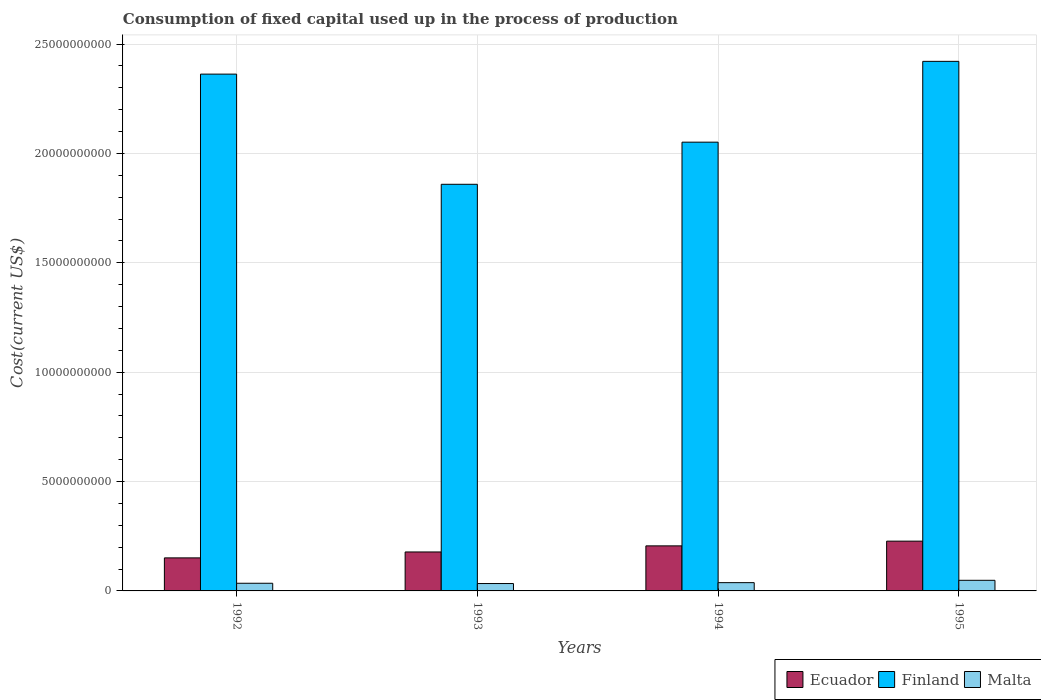How many different coloured bars are there?
Provide a short and direct response. 3. How many bars are there on the 4th tick from the right?
Ensure brevity in your answer.  3. What is the amount consumed in the process of production in Ecuador in 1995?
Give a very brief answer. 2.28e+09. Across all years, what is the maximum amount consumed in the process of production in Finland?
Make the answer very short. 2.42e+1. Across all years, what is the minimum amount consumed in the process of production in Ecuador?
Your answer should be compact. 1.51e+09. In which year was the amount consumed in the process of production in Ecuador maximum?
Your answer should be compact. 1995. In which year was the amount consumed in the process of production in Malta minimum?
Provide a short and direct response. 1993. What is the total amount consumed in the process of production in Malta in the graph?
Ensure brevity in your answer.  1.55e+09. What is the difference between the amount consumed in the process of production in Finland in 1992 and that in 1993?
Keep it short and to the point. 5.04e+09. What is the difference between the amount consumed in the process of production in Ecuador in 1994 and the amount consumed in the process of production in Finland in 1995?
Provide a short and direct response. -2.22e+1. What is the average amount consumed in the process of production in Finland per year?
Your answer should be very brief. 2.17e+1. In the year 1995, what is the difference between the amount consumed in the process of production in Ecuador and amount consumed in the process of production in Malta?
Your response must be concise. 1.79e+09. What is the ratio of the amount consumed in the process of production in Ecuador in 1992 to that in 1994?
Your answer should be very brief. 0.73. What is the difference between the highest and the second highest amount consumed in the process of production in Finland?
Give a very brief answer. 5.84e+08. What is the difference between the highest and the lowest amount consumed in the process of production in Malta?
Your response must be concise. 1.48e+08. Is the sum of the amount consumed in the process of production in Malta in 1992 and 1995 greater than the maximum amount consumed in the process of production in Finland across all years?
Keep it short and to the point. No. What does the 2nd bar from the left in 1992 represents?
Make the answer very short. Finland. What does the 1st bar from the right in 1994 represents?
Ensure brevity in your answer.  Malta. Is it the case that in every year, the sum of the amount consumed in the process of production in Finland and amount consumed in the process of production in Ecuador is greater than the amount consumed in the process of production in Malta?
Keep it short and to the point. Yes. Are all the bars in the graph horizontal?
Give a very brief answer. No. Are the values on the major ticks of Y-axis written in scientific E-notation?
Provide a succinct answer. No. Does the graph contain any zero values?
Ensure brevity in your answer.  No. Where does the legend appear in the graph?
Keep it short and to the point. Bottom right. What is the title of the graph?
Give a very brief answer. Consumption of fixed capital used up in the process of production. Does "Tajikistan" appear as one of the legend labels in the graph?
Your answer should be very brief. No. What is the label or title of the X-axis?
Give a very brief answer. Years. What is the label or title of the Y-axis?
Give a very brief answer. Cost(current US$). What is the Cost(current US$) in Ecuador in 1992?
Keep it short and to the point. 1.51e+09. What is the Cost(current US$) in Finland in 1992?
Make the answer very short. 2.36e+1. What is the Cost(current US$) of Malta in 1992?
Offer a very short reply. 3.50e+08. What is the Cost(current US$) in Ecuador in 1993?
Offer a very short reply. 1.78e+09. What is the Cost(current US$) in Finland in 1993?
Your response must be concise. 1.86e+1. What is the Cost(current US$) in Malta in 1993?
Your answer should be very brief. 3.37e+08. What is the Cost(current US$) in Ecuador in 1994?
Ensure brevity in your answer.  2.06e+09. What is the Cost(current US$) in Finland in 1994?
Make the answer very short. 2.05e+1. What is the Cost(current US$) of Malta in 1994?
Offer a terse response. 3.78e+08. What is the Cost(current US$) of Ecuador in 1995?
Ensure brevity in your answer.  2.28e+09. What is the Cost(current US$) of Finland in 1995?
Offer a terse response. 2.42e+1. What is the Cost(current US$) in Malta in 1995?
Provide a short and direct response. 4.86e+08. Across all years, what is the maximum Cost(current US$) of Ecuador?
Keep it short and to the point. 2.28e+09. Across all years, what is the maximum Cost(current US$) in Finland?
Your answer should be very brief. 2.42e+1. Across all years, what is the maximum Cost(current US$) of Malta?
Offer a very short reply. 4.86e+08. Across all years, what is the minimum Cost(current US$) of Ecuador?
Provide a succinct answer. 1.51e+09. Across all years, what is the minimum Cost(current US$) of Finland?
Give a very brief answer. 1.86e+1. Across all years, what is the minimum Cost(current US$) of Malta?
Provide a short and direct response. 3.37e+08. What is the total Cost(current US$) of Ecuador in the graph?
Make the answer very short. 7.63e+09. What is the total Cost(current US$) in Finland in the graph?
Provide a short and direct response. 8.69e+1. What is the total Cost(current US$) of Malta in the graph?
Give a very brief answer. 1.55e+09. What is the difference between the Cost(current US$) in Ecuador in 1992 and that in 1993?
Offer a very short reply. -2.71e+08. What is the difference between the Cost(current US$) of Finland in 1992 and that in 1993?
Your answer should be compact. 5.04e+09. What is the difference between the Cost(current US$) of Malta in 1992 and that in 1993?
Your response must be concise. 1.30e+07. What is the difference between the Cost(current US$) of Ecuador in 1992 and that in 1994?
Make the answer very short. -5.49e+08. What is the difference between the Cost(current US$) in Finland in 1992 and that in 1994?
Your answer should be compact. 3.11e+09. What is the difference between the Cost(current US$) in Malta in 1992 and that in 1994?
Ensure brevity in your answer.  -2.76e+07. What is the difference between the Cost(current US$) in Ecuador in 1992 and that in 1995?
Provide a short and direct response. -7.65e+08. What is the difference between the Cost(current US$) in Finland in 1992 and that in 1995?
Your response must be concise. -5.84e+08. What is the difference between the Cost(current US$) in Malta in 1992 and that in 1995?
Offer a terse response. -1.35e+08. What is the difference between the Cost(current US$) of Ecuador in 1993 and that in 1994?
Your answer should be very brief. -2.78e+08. What is the difference between the Cost(current US$) of Finland in 1993 and that in 1994?
Keep it short and to the point. -1.93e+09. What is the difference between the Cost(current US$) in Malta in 1993 and that in 1994?
Make the answer very short. -4.06e+07. What is the difference between the Cost(current US$) in Ecuador in 1993 and that in 1995?
Provide a short and direct response. -4.94e+08. What is the difference between the Cost(current US$) in Finland in 1993 and that in 1995?
Offer a terse response. -5.62e+09. What is the difference between the Cost(current US$) of Malta in 1993 and that in 1995?
Offer a very short reply. -1.48e+08. What is the difference between the Cost(current US$) of Ecuador in 1994 and that in 1995?
Make the answer very short. -2.16e+08. What is the difference between the Cost(current US$) in Finland in 1994 and that in 1995?
Keep it short and to the point. -3.69e+09. What is the difference between the Cost(current US$) of Malta in 1994 and that in 1995?
Your answer should be compact. -1.08e+08. What is the difference between the Cost(current US$) of Ecuador in 1992 and the Cost(current US$) of Finland in 1993?
Make the answer very short. -1.71e+1. What is the difference between the Cost(current US$) of Ecuador in 1992 and the Cost(current US$) of Malta in 1993?
Provide a succinct answer. 1.17e+09. What is the difference between the Cost(current US$) of Finland in 1992 and the Cost(current US$) of Malta in 1993?
Your response must be concise. 2.33e+1. What is the difference between the Cost(current US$) of Ecuador in 1992 and the Cost(current US$) of Finland in 1994?
Provide a succinct answer. -1.90e+1. What is the difference between the Cost(current US$) in Ecuador in 1992 and the Cost(current US$) in Malta in 1994?
Provide a succinct answer. 1.13e+09. What is the difference between the Cost(current US$) of Finland in 1992 and the Cost(current US$) of Malta in 1994?
Provide a succinct answer. 2.32e+1. What is the difference between the Cost(current US$) in Ecuador in 1992 and the Cost(current US$) in Finland in 1995?
Give a very brief answer. -2.27e+1. What is the difference between the Cost(current US$) of Ecuador in 1992 and the Cost(current US$) of Malta in 1995?
Make the answer very short. 1.02e+09. What is the difference between the Cost(current US$) in Finland in 1992 and the Cost(current US$) in Malta in 1995?
Give a very brief answer. 2.31e+1. What is the difference between the Cost(current US$) of Ecuador in 1993 and the Cost(current US$) of Finland in 1994?
Keep it short and to the point. -1.87e+1. What is the difference between the Cost(current US$) in Ecuador in 1993 and the Cost(current US$) in Malta in 1994?
Provide a succinct answer. 1.40e+09. What is the difference between the Cost(current US$) of Finland in 1993 and the Cost(current US$) of Malta in 1994?
Make the answer very short. 1.82e+1. What is the difference between the Cost(current US$) of Ecuador in 1993 and the Cost(current US$) of Finland in 1995?
Keep it short and to the point. -2.24e+1. What is the difference between the Cost(current US$) of Ecuador in 1993 and the Cost(current US$) of Malta in 1995?
Make the answer very short. 1.30e+09. What is the difference between the Cost(current US$) in Finland in 1993 and the Cost(current US$) in Malta in 1995?
Your answer should be compact. 1.81e+1. What is the difference between the Cost(current US$) in Ecuador in 1994 and the Cost(current US$) in Finland in 1995?
Keep it short and to the point. -2.22e+1. What is the difference between the Cost(current US$) of Ecuador in 1994 and the Cost(current US$) of Malta in 1995?
Make the answer very short. 1.57e+09. What is the difference between the Cost(current US$) in Finland in 1994 and the Cost(current US$) in Malta in 1995?
Keep it short and to the point. 2.00e+1. What is the average Cost(current US$) in Ecuador per year?
Offer a very short reply. 1.91e+09. What is the average Cost(current US$) in Finland per year?
Give a very brief answer. 2.17e+1. What is the average Cost(current US$) in Malta per year?
Your answer should be compact. 3.88e+08. In the year 1992, what is the difference between the Cost(current US$) in Ecuador and Cost(current US$) in Finland?
Ensure brevity in your answer.  -2.21e+1. In the year 1992, what is the difference between the Cost(current US$) in Ecuador and Cost(current US$) in Malta?
Make the answer very short. 1.16e+09. In the year 1992, what is the difference between the Cost(current US$) in Finland and Cost(current US$) in Malta?
Provide a succinct answer. 2.33e+1. In the year 1993, what is the difference between the Cost(current US$) of Ecuador and Cost(current US$) of Finland?
Your answer should be compact. -1.68e+1. In the year 1993, what is the difference between the Cost(current US$) in Ecuador and Cost(current US$) in Malta?
Offer a terse response. 1.44e+09. In the year 1993, what is the difference between the Cost(current US$) of Finland and Cost(current US$) of Malta?
Your answer should be compact. 1.83e+1. In the year 1994, what is the difference between the Cost(current US$) of Ecuador and Cost(current US$) of Finland?
Your answer should be compact. -1.85e+1. In the year 1994, what is the difference between the Cost(current US$) of Ecuador and Cost(current US$) of Malta?
Your answer should be very brief. 1.68e+09. In the year 1994, what is the difference between the Cost(current US$) in Finland and Cost(current US$) in Malta?
Ensure brevity in your answer.  2.01e+1. In the year 1995, what is the difference between the Cost(current US$) in Ecuador and Cost(current US$) in Finland?
Your response must be concise. -2.19e+1. In the year 1995, what is the difference between the Cost(current US$) of Ecuador and Cost(current US$) of Malta?
Offer a very short reply. 1.79e+09. In the year 1995, what is the difference between the Cost(current US$) of Finland and Cost(current US$) of Malta?
Keep it short and to the point. 2.37e+1. What is the ratio of the Cost(current US$) in Ecuador in 1992 to that in 1993?
Ensure brevity in your answer.  0.85. What is the ratio of the Cost(current US$) in Finland in 1992 to that in 1993?
Keep it short and to the point. 1.27. What is the ratio of the Cost(current US$) in Ecuador in 1992 to that in 1994?
Your answer should be very brief. 0.73. What is the ratio of the Cost(current US$) of Finland in 1992 to that in 1994?
Provide a short and direct response. 1.15. What is the ratio of the Cost(current US$) of Malta in 1992 to that in 1994?
Ensure brevity in your answer.  0.93. What is the ratio of the Cost(current US$) of Ecuador in 1992 to that in 1995?
Make the answer very short. 0.66. What is the ratio of the Cost(current US$) in Finland in 1992 to that in 1995?
Ensure brevity in your answer.  0.98. What is the ratio of the Cost(current US$) of Malta in 1992 to that in 1995?
Your answer should be compact. 0.72. What is the ratio of the Cost(current US$) of Ecuador in 1993 to that in 1994?
Provide a succinct answer. 0.86. What is the ratio of the Cost(current US$) in Finland in 1993 to that in 1994?
Provide a succinct answer. 0.91. What is the ratio of the Cost(current US$) of Malta in 1993 to that in 1994?
Provide a succinct answer. 0.89. What is the ratio of the Cost(current US$) in Ecuador in 1993 to that in 1995?
Your answer should be very brief. 0.78. What is the ratio of the Cost(current US$) of Finland in 1993 to that in 1995?
Offer a terse response. 0.77. What is the ratio of the Cost(current US$) in Malta in 1993 to that in 1995?
Provide a short and direct response. 0.69. What is the ratio of the Cost(current US$) of Ecuador in 1994 to that in 1995?
Keep it short and to the point. 0.91. What is the ratio of the Cost(current US$) of Finland in 1994 to that in 1995?
Offer a very short reply. 0.85. What is the ratio of the Cost(current US$) in Malta in 1994 to that in 1995?
Offer a very short reply. 0.78. What is the difference between the highest and the second highest Cost(current US$) of Ecuador?
Make the answer very short. 2.16e+08. What is the difference between the highest and the second highest Cost(current US$) in Finland?
Your answer should be compact. 5.84e+08. What is the difference between the highest and the second highest Cost(current US$) of Malta?
Make the answer very short. 1.08e+08. What is the difference between the highest and the lowest Cost(current US$) in Ecuador?
Give a very brief answer. 7.65e+08. What is the difference between the highest and the lowest Cost(current US$) of Finland?
Your answer should be very brief. 5.62e+09. What is the difference between the highest and the lowest Cost(current US$) of Malta?
Keep it short and to the point. 1.48e+08. 